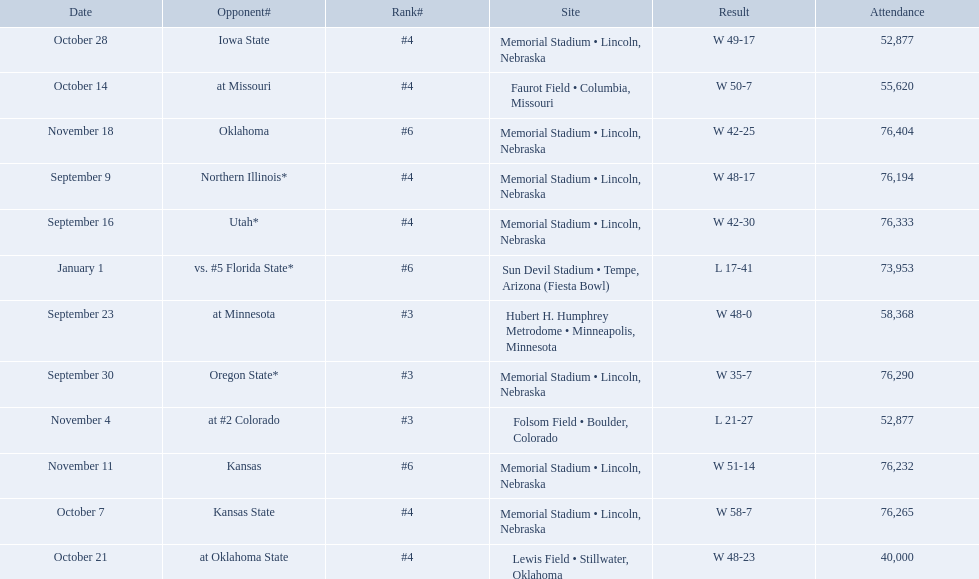Which opponenets did the nebraska cornhuskers score fewer than 40 points against? Oregon State*, at #2 Colorado, vs. #5 Florida State*. Of these games, which ones had an attendance of greater than 70,000? Oregon State*, vs. #5 Florida State*. Which of these opponents did they beat? Oregon State*. How many people were in attendance at that game? 76,290. When did nebraska play oregon state? September 30. What was the attendance at the september 30 game? 76,290. 